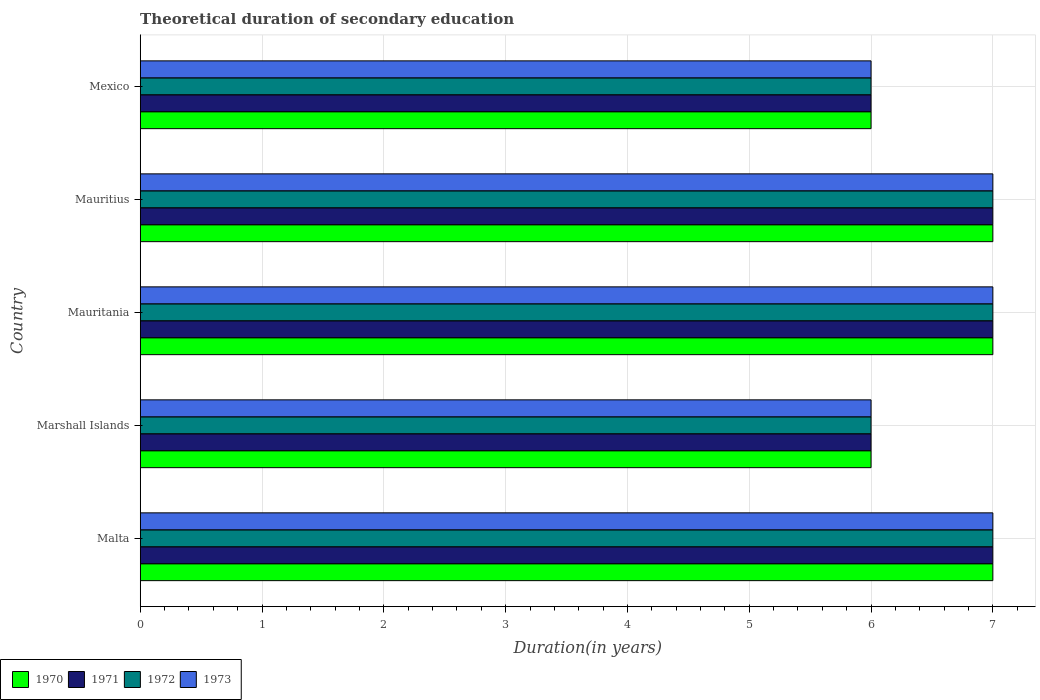How many groups of bars are there?
Give a very brief answer. 5. Are the number of bars on each tick of the Y-axis equal?
Offer a very short reply. Yes. How many bars are there on the 3rd tick from the top?
Ensure brevity in your answer.  4. How many bars are there on the 5th tick from the bottom?
Offer a terse response. 4. What is the label of the 2nd group of bars from the top?
Keep it short and to the point. Mauritius. In how many cases, is the number of bars for a given country not equal to the number of legend labels?
Ensure brevity in your answer.  0. What is the total theoretical duration of secondary education in 1972 in Mexico?
Give a very brief answer. 6. Across all countries, what is the minimum total theoretical duration of secondary education in 1970?
Make the answer very short. 6. In which country was the total theoretical duration of secondary education in 1970 maximum?
Give a very brief answer. Malta. In which country was the total theoretical duration of secondary education in 1973 minimum?
Offer a terse response. Marshall Islands. What is the difference between the total theoretical duration of secondary education in 1971 in Malta and that in Marshall Islands?
Offer a very short reply. 1. What is the difference between the total theoretical duration of secondary education in 1973 in Mauritania and the total theoretical duration of secondary education in 1972 in Mauritius?
Your answer should be compact. 0. What is the average total theoretical duration of secondary education in 1972 per country?
Your response must be concise. 6.6. What is the ratio of the total theoretical duration of secondary education in 1972 in Marshall Islands to that in Mauritius?
Your answer should be very brief. 0.86. Is the total theoretical duration of secondary education in 1972 in Malta less than that in Mexico?
Keep it short and to the point. No. Is the difference between the total theoretical duration of secondary education in 1971 in Mauritania and Mexico greater than the difference between the total theoretical duration of secondary education in 1973 in Mauritania and Mexico?
Your answer should be compact. No. What is the difference between the highest and the lowest total theoretical duration of secondary education in 1970?
Give a very brief answer. 1. Is it the case that in every country, the sum of the total theoretical duration of secondary education in 1970 and total theoretical duration of secondary education in 1973 is greater than the sum of total theoretical duration of secondary education in 1971 and total theoretical duration of secondary education in 1972?
Your answer should be very brief. No. What does the 3rd bar from the bottom in Malta represents?
Provide a short and direct response. 1972. Is it the case that in every country, the sum of the total theoretical duration of secondary education in 1971 and total theoretical duration of secondary education in 1970 is greater than the total theoretical duration of secondary education in 1973?
Offer a terse response. Yes. How many bars are there?
Ensure brevity in your answer.  20. How many legend labels are there?
Your answer should be compact. 4. What is the title of the graph?
Make the answer very short. Theoretical duration of secondary education. What is the label or title of the X-axis?
Ensure brevity in your answer.  Duration(in years). What is the label or title of the Y-axis?
Offer a very short reply. Country. What is the Duration(in years) of 1970 in Malta?
Your answer should be very brief. 7. What is the Duration(in years) of 1971 in Malta?
Offer a terse response. 7. What is the Duration(in years) of 1971 in Marshall Islands?
Make the answer very short. 6. What is the Duration(in years) in 1972 in Marshall Islands?
Ensure brevity in your answer.  6. What is the Duration(in years) of 1970 in Mauritania?
Ensure brevity in your answer.  7. What is the Duration(in years) in 1971 in Mauritius?
Keep it short and to the point. 7. What is the Duration(in years) in 1972 in Mauritius?
Offer a terse response. 7. What is the Duration(in years) of 1972 in Mexico?
Keep it short and to the point. 6. What is the Duration(in years) of 1973 in Mexico?
Provide a succinct answer. 6. Across all countries, what is the maximum Duration(in years) of 1970?
Your answer should be very brief. 7. Across all countries, what is the minimum Duration(in years) in 1970?
Provide a short and direct response. 6. Across all countries, what is the minimum Duration(in years) of 1973?
Offer a very short reply. 6. What is the total Duration(in years) of 1970 in the graph?
Keep it short and to the point. 33. What is the total Duration(in years) of 1972 in the graph?
Your response must be concise. 33. What is the total Duration(in years) of 1973 in the graph?
Your answer should be very brief. 33. What is the difference between the Duration(in years) of 1970 in Malta and that in Marshall Islands?
Give a very brief answer. 1. What is the difference between the Duration(in years) of 1972 in Malta and that in Marshall Islands?
Provide a short and direct response. 1. What is the difference between the Duration(in years) of 1973 in Malta and that in Marshall Islands?
Your answer should be very brief. 1. What is the difference between the Duration(in years) in 1970 in Malta and that in Mauritania?
Keep it short and to the point. 0. What is the difference between the Duration(in years) in 1971 in Malta and that in Mauritania?
Ensure brevity in your answer.  0. What is the difference between the Duration(in years) in 1972 in Malta and that in Mauritania?
Give a very brief answer. 0. What is the difference between the Duration(in years) of 1973 in Malta and that in Mauritania?
Make the answer very short. 0. What is the difference between the Duration(in years) in 1972 in Malta and that in Mauritius?
Your answer should be compact. 0. What is the difference between the Duration(in years) in 1971 in Malta and that in Mexico?
Offer a very short reply. 1. What is the difference between the Duration(in years) of 1973 in Malta and that in Mexico?
Offer a terse response. 1. What is the difference between the Duration(in years) in 1970 in Marshall Islands and that in Mauritania?
Keep it short and to the point. -1. What is the difference between the Duration(in years) in 1971 in Marshall Islands and that in Mauritania?
Provide a short and direct response. -1. What is the difference between the Duration(in years) in 1971 in Marshall Islands and that in Mauritius?
Keep it short and to the point. -1. What is the difference between the Duration(in years) in 1970 in Marshall Islands and that in Mexico?
Make the answer very short. 0. What is the difference between the Duration(in years) of 1970 in Mauritania and that in Mauritius?
Your answer should be very brief. 0. What is the difference between the Duration(in years) in 1971 in Mauritania and that in Mauritius?
Keep it short and to the point. 0. What is the difference between the Duration(in years) in 1972 in Mauritania and that in Mauritius?
Make the answer very short. 0. What is the difference between the Duration(in years) in 1972 in Mauritania and that in Mexico?
Keep it short and to the point. 1. What is the difference between the Duration(in years) in 1973 in Mauritania and that in Mexico?
Provide a short and direct response. 1. What is the difference between the Duration(in years) in 1970 in Mauritius and that in Mexico?
Your response must be concise. 1. What is the difference between the Duration(in years) of 1972 in Mauritius and that in Mexico?
Your response must be concise. 1. What is the difference between the Duration(in years) of 1973 in Mauritius and that in Mexico?
Offer a very short reply. 1. What is the difference between the Duration(in years) in 1970 in Malta and the Duration(in years) in 1971 in Marshall Islands?
Your answer should be compact. 1. What is the difference between the Duration(in years) of 1970 in Malta and the Duration(in years) of 1972 in Marshall Islands?
Offer a very short reply. 1. What is the difference between the Duration(in years) of 1971 in Malta and the Duration(in years) of 1972 in Marshall Islands?
Give a very brief answer. 1. What is the difference between the Duration(in years) of 1971 in Malta and the Duration(in years) of 1973 in Marshall Islands?
Offer a very short reply. 1. What is the difference between the Duration(in years) in 1970 in Malta and the Duration(in years) in 1972 in Mauritania?
Offer a very short reply. 0. What is the difference between the Duration(in years) of 1972 in Malta and the Duration(in years) of 1973 in Mauritania?
Provide a short and direct response. 0. What is the difference between the Duration(in years) in 1970 in Malta and the Duration(in years) in 1972 in Mauritius?
Provide a short and direct response. 0. What is the difference between the Duration(in years) of 1971 in Malta and the Duration(in years) of 1972 in Mauritius?
Your answer should be compact. 0. What is the difference between the Duration(in years) of 1970 in Malta and the Duration(in years) of 1972 in Mexico?
Offer a very short reply. 1. What is the difference between the Duration(in years) in 1971 in Malta and the Duration(in years) in 1972 in Mexico?
Provide a succinct answer. 1. What is the difference between the Duration(in years) in 1970 in Marshall Islands and the Duration(in years) in 1971 in Mauritania?
Ensure brevity in your answer.  -1. What is the difference between the Duration(in years) in 1971 in Marshall Islands and the Duration(in years) in 1973 in Mauritania?
Your answer should be very brief. -1. What is the difference between the Duration(in years) in 1970 in Marshall Islands and the Duration(in years) in 1973 in Mauritius?
Your answer should be compact. -1. What is the difference between the Duration(in years) of 1972 in Marshall Islands and the Duration(in years) of 1973 in Mauritius?
Keep it short and to the point. -1. What is the difference between the Duration(in years) of 1971 in Marshall Islands and the Duration(in years) of 1973 in Mexico?
Keep it short and to the point. 0. What is the difference between the Duration(in years) in 1971 in Mauritania and the Duration(in years) in 1973 in Mauritius?
Keep it short and to the point. 0. What is the difference between the Duration(in years) of 1970 in Mauritania and the Duration(in years) of 1971 in Mexico?
Your answer should be compact. 1. What is the difference between the Duration(in years) of 1970 in Mauritania and the Duration(in years) of 1972 in Mexico?
Ensure brevity in your answer.  1. What is the difference between the Duration(in years) of 1970 in Mauritania and the Duration(in years) of 1973 in Mexico?
Offer a terse response. 1. What is the difference between the Duration(in years) of 1971 in Mauritania and the Duration(in years) of 1972 in Mexico?
Your response must be concise. 1. What is the difference between the Duration(in years) in 1971 in Mauritania and the Duration(in years) in 1973 in Mexico?
Offer a terse response. 1. What is the difference between the Duration(in years) of 1970 in Mauritius and the Duration(in years) of 1971 in Mexico?
Your answer should be compact. 1. What is the difference between the Duration(in years) of 1970 in Mauritius and the Duration(in years) of 1973 in Mexico?
Your answer should be very brief. 1. What is the difference between the Duration(in years) of 1971 in Mauritius and the Duration(in years) of 1972 in Mexico?
Offer a terse response. 1. What is the difference between the Duration(in years) of 1972 in Mauritius and the Duration(in years) of 1973 in Mexico?
Ensure brevity in your answer.  1. What is the average Duration(in years) of 1970 per country?
Make the answer very short. 6.6. What is the average Duration(in years) in 1971 per country?
Offer a very short reply. 6.6. What is the average Duration(in years) of 1973 per country?
Keep it short and to the point. 6.6. What is the difference between the Duration(in years) in 1972 and Duration(in years) in 1973 in Malta?
Your answer should be compact. 0. What is the difference between the Duration(in years) in 1970 and Duration(in years) in 1972 in Marshall Islands?
Give a very brief answer. 0. What is the difference between the Duration(in years) in 1971 and Duration(in years) in 1972 in Marshall Islands?
Ensure brevity in your answer.  0. What is the difference between the Duration(in years) in 1972 and Duration(in years) in 1973 in Marshall Islands?
Your answer should be very brief. 0. What is the difference between the Duration(in years) in 1970 and Duration(in years) in 1972 in Mauritania?
Provide a short and direct response. 0. What is the difference between the Duration(in years) in 1970 and Duration(in years) in 1973 in Mauritania?
Your answer should be very brief. 0. What is the difference between the Duration(in years) of 1971 and Duration(in years) of 1972 in Mauritania?
Offer a terse response. 0. What is the difference between the Duration(in years) of 1971 and Duration(in years) of 1973 in Mauritania?
Make the answer very short. 0. What is the difference between the Duration(in years) of 1970 and Duration(in years) of 1971 in Mauritius?
Give a very brief answer. 0. What is the difference between the Duration(in years) of 1970 and Duration(in years) of 1973 in Mauritius?
Ensure brevity in your answer.  0. What is the difference between the Duration(in years) in 1972 and Duration(in years) in 1973 in Mauritius?
Offer a terse response. 0. What is the difference between the Duration(in years) in 1972 and Duration(in years) in 1973 in Mexico?
Your answer should be compact. 0. What is the ratio of the Duration(in years) in 1972 in Malta to that in Marshall Islands?
Make the answer very short. 1.17. What is the ratio of the Duration(in years) of 1970 in Malta to that in Mauritania?
Your answer should be compact. 1. What is the ratio of the Duration(in years) in 1971 in Malta to that in Mauritania?
Make the answer very short. 1. What is the ratio of the Duration(in years) in 1973 in Malta to that in Mauritania?
Make the answer very short. 1. What is the ratio of the Duration(in years) in 1970 in Malta to that in Mauritius?
Provide a succinct answer. 1. What is the ratio of the Duration(in years) of 1970 in Malta to that in Mexico?
Your answer should be very brief. 1.17. What is the ratio of the Duration(in years) of 1970 in Marshall Islands to that in Mauritania?
Offer a very short reply. 0.86. What is the ratio of the Duration(in years) in 1972 in Marshall Islands to that in Mauritania?
Ensure brevity in your answer.  0.86. What is the ratio of the Duration(in years) in 1973 in Marshall Islands to that in Mauritania?
Your response must be concise. 0.86. What is the ratio of the Duration(in years) in 1970 in Marshall Islands to that in Mauritius?
Offer a very short reply. 0.86. What is the ratio of the Duration(in years) in 1971 in Marshall Islands to that in Mauritius?
Ensure brevity in your answer.  0.86. What is the ratio of the Duration(in years) of 1972 in Marshall Islands to that in Mauritius?
Your response must be concise. 0.86. What is the ratio of the Duration(in years) of 1972 in Mauritania to that in Mauritius?
Make the answer very short. 1. What is the ratio of the Duration(in years) of 1973 in Mauritania to that in Mauritius?
Your answer should be very brief. 1. What is the ratio of the Duration(in years) in 1970 in Mauritania to that in Mexico?
Offer a very short reply. 1.17. What is the ratio of the Duration(in years) in 1971 in Mauritania to that in Mexico?
Provide a succinct answer. 1.17. What is the ratio of the Duration(in years) of 1972 in Mauritania to that in Mexico?
Provide a succinct answer. 1.17. What is the ratio of the Duration(in years) in 1973 in Mauritania to that in Mexico?
Your response must be concise. 1.17. What is the ratio of the Duration(in years) of 1972 in Mauritius to that in Mexico?
Offer a very short reply. 1.17. What is the difference between the highest and the second highest Duration(in years) of 1971?
Make the answer very short. 0. What is the difference between the highest and the lowest Duration(in years) of 1970?
Give a very brief answer. 1. What is the difference between the highest and the lowest Duration(in years) of 1971?
Offer a very short reply. 1. What is the difference between the highest and the lowest Duration(in years) in 1973?
Offer a terse response. 1. 